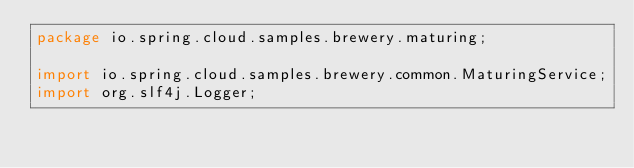<code> <loc_0><loc_0><loc_500><loc_500><_Java_>package io.spring.cloud.samples.brewery.maturing;

import io.spring.cloud.samples.brewery.common.MaturingService;
import org.slf4j.Logger;
</code> 